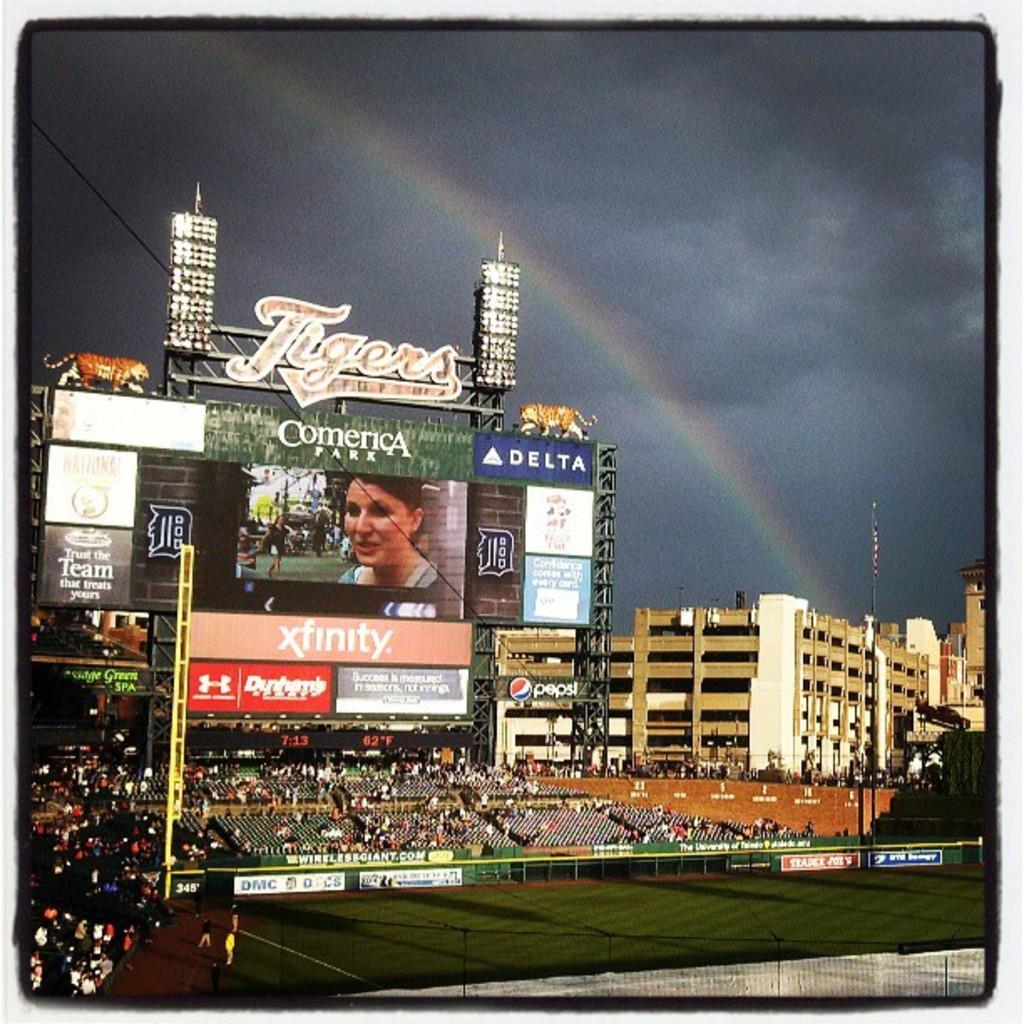How would you summarize this image in a sentence or two? In this image there is ground. Few persons are standing on it. Behind there is a fence. There are few persons sitting behind the fence. There are few poles. Left side there are few persons. There is a building having few boards attached to it, beside there are few buildings. Top of image there is sky having rainbow. 